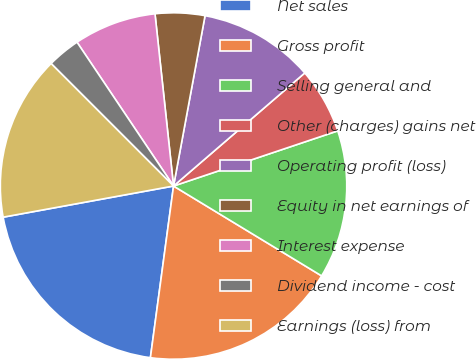Convert chart. <chart><loc_0><loc_0><loc_500><loc_500><pie_chart><fcel>Net sales<fcel>Gross profit<fcel>Selling general and<fcel>Other (charges) gains net<fcel>Operating profit (loss)<fcel>Equity in net earnings of<fcel>Interest expense<fcel>Dividend income - cost<fcel>Earnings (loss) from<nl><fcel>19.99%<fcel>18.45%<fcel>13.84%<fcel>6.16%<fcel>10.77%<fcel>4.62%<fcel>7.7%<fcel>3.09%<fcel>15.38%<nl></chart> 